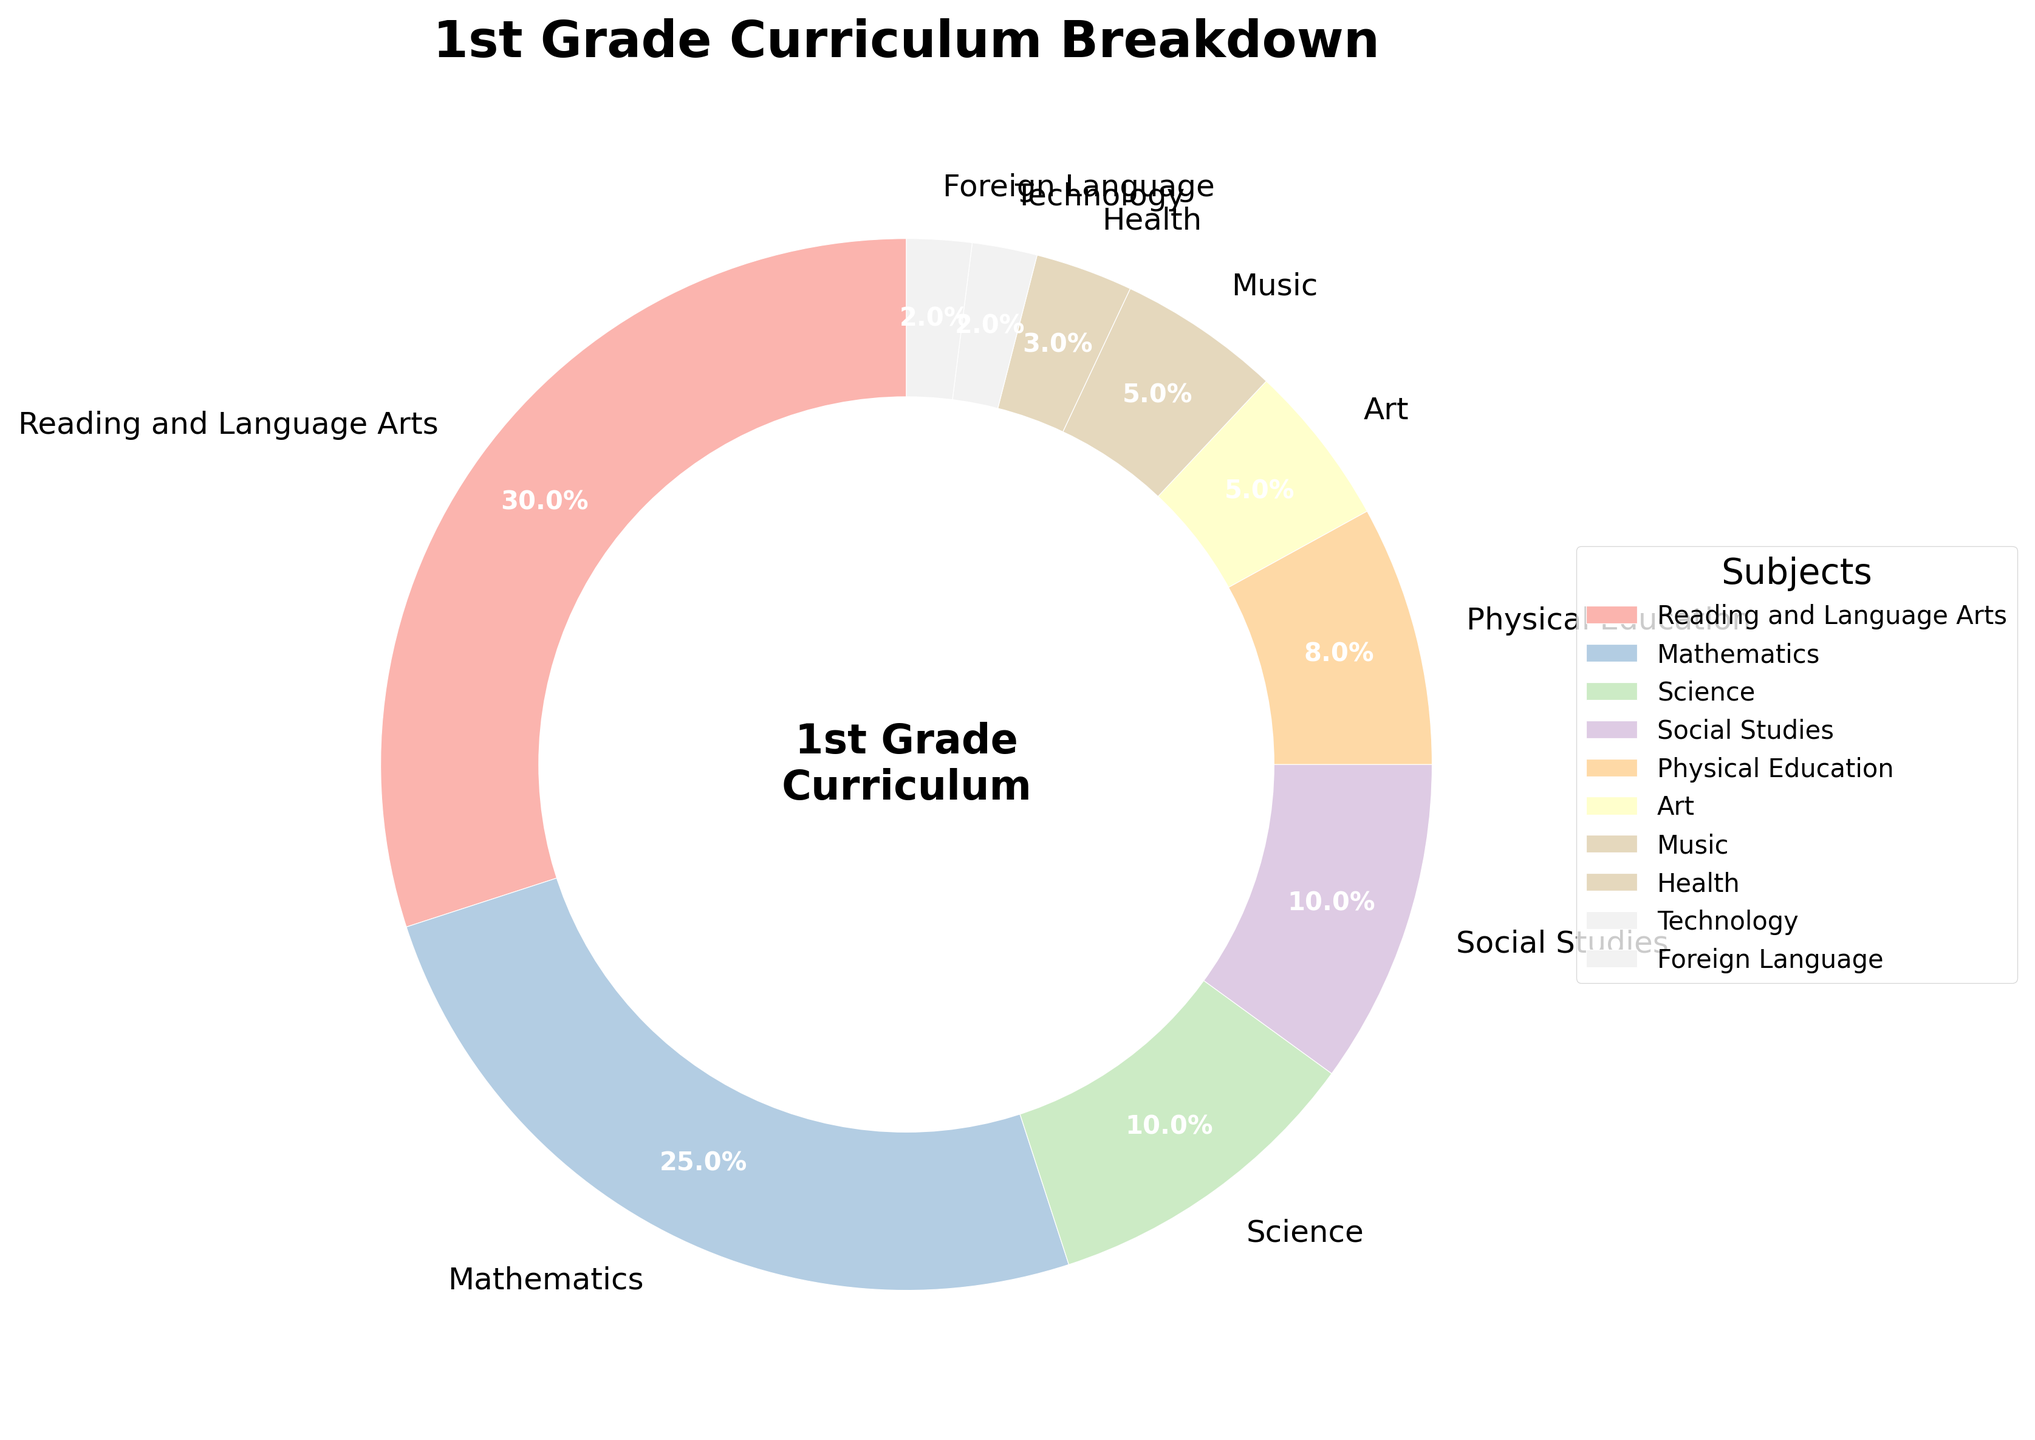What is the percentage of the subject with the smallest portion in the curriculum? The smallest portion can be found by identifying the smallest percentage in the pie chart, which is 2%, assigned to both Technology and Foreign Language.
Answer: 2% Which subject has the largest portion of the curriculum? The largest percentage in the pie chart is represented by Reading and Language Arts, which is 30%.
Answer: Reading and Language Arts How many subjects have a percentage equal to or less than 5%? The pie chart shows Art, Music, Health, Technology, and Foreign Language with respective percentages of 5%, 5%, 3%, 2%, and 2%. This totals to five subjects.
Answer: 5 What is the combined percentage of the Science and Social Studies subjects? The percentages for Science and Social Studies are 10% and 10%, respectively. Adding these gives a total of 20%.
Answer: 20% Which subjects have an equal percentage in the pie chart, and what is that percentage? By examining the pie chart, we see that the percentages for Art and Music are both 5%.
Answer: Art and Music, 5% Is the percentage of Physical Education greater than that of Health and Technology combined? Physical Education has a percentage of 8%. The combined percentage of Health and Technology is 3% + 2% = 5%. Since 8% is greater than 5%, Physical Education has a higher percentage.
Answer: Yes What is the combined portion of subjects focused on the arts (Art and Music)? The percentages for Art and Music are both 5%. Thus, the combined portion is 5% + 5% = 10%.
Answer: 10% What is the percentage difference between Mathematics and Science? Mathematics is 25% and Science is 10%. The difference is 25% - 10% = 15%.
Answer: 15% Which subject is represented by the color light pink in the chart? By looking at the color scheme and legend in the pie chart, we can identify that Foreign Language is represented by the light pink color.
Answer: Foreign Language If Technology and Foreign Language are combined into a single subject, what would their combined percentage be? The individual percentages are 2% each. Adding these gives 2% + 2% = 4%.
Answer: 4% 